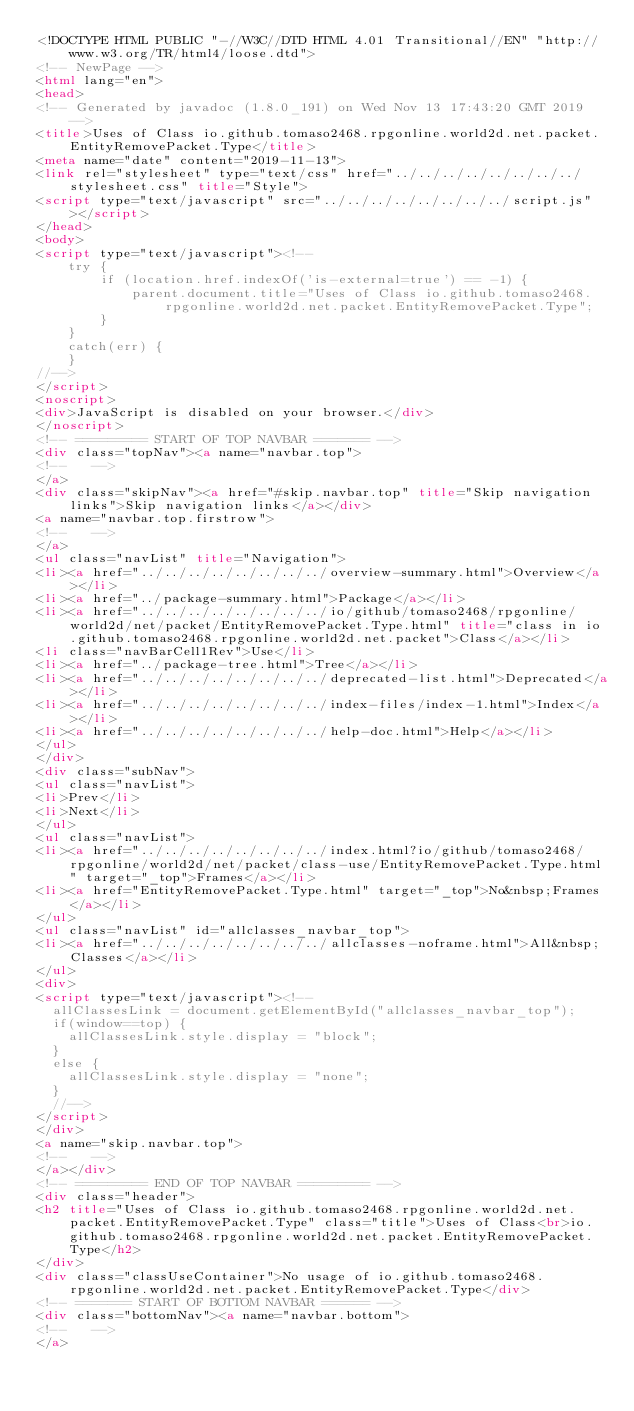Convert code to text. <code><loc_0><loc_0><loc_500><loc_500><_HTML_><!DOCTYPE HTML PUBLIC "-//W3C//DTD HTML 4.01 Transitional//EN" "http://www.w3.org/TR/html4/loose.dtd">
<!-- NewPage -->
<html lang="en">
<head>
<!-- Generated by javadoc (1.8.0_191) on Wed Nov 13 17:43:20 GMT 2019 -->
<title>Uses of Class io.github.tomaso2468.rpgonline.world2d.net.packet.EntityRemovePacket.Type</title>
<meta name="date" content="2019-11-13">
<link rel="stylesheet" type="text/css" href="../../../../../../../../stylesheet.css" title="Style">
<script type="text/javascript" src="../../../../../../../../script.js"></script>
</head>
<body>
<script type="text/javascript"><!--
    try {
        if (location.href.indexOf('is-external=true') == -1) {
            parent.document.title="Uses of Class io.github.tomaso2468.rpgonline.world2d.net.packet.EntityRemovePacket.Type";
        }
    }
    catch(err) {
    }
//-->
</script>
<noscript>
<div>JavaScript is disabled on your browser.</div>
</noscript>
<!-- ========= START OF TOP NAVBAR ======= -->
<div class="topNav"><a name="navbar.top">
<!--   -->
</a>
<div class="skipNav"><a href="#skip.navbar.top" title="Skip navigation links">Skip navigation links</a></div>
<a name="navbar.top.firstrow">
<!--   -->
</a>
<ul class="navList" title="Navigation">
<li><a href="../../../../../../../../overview-summary.html">Overview</a></li>
<li><a href="../package-summary.html">Package</a></li>
<li><a href="../../../../../../../../io/github/tomaso2468/rpgonline/world2d/net/packet/EntityRemovePacket.Type.html" title="class in io.github.tomaso2468.rpgonline.world2d.net.packet">Class</a></li>
<li class="navBarCell1Rev">Use</li>
<li><a href="../package-tree.html">Tree</a></li>
<li><a href="../../../../../../../../deprecated-list.html">Deprecated</a></li>
<li><a href="../../../../../../../../index-files/index-1.html">Index</a></li>
<li><a href="../../../../../../../../help-doc.html">Help</a></li>
</ul>
</div>
<div class="subNav">
<ul class="navList">
<li>Prev</li>
<li>Next</li>
</ul>
<ul class="navList">
<li><a href="../../../../../../../../index.html?io/github/tomaso2468/rpgonline/world2d/net/packet/class-use/EntityRemovePacket.Type.html" target="_top">Frames</a></li>
<li><a href="EntityRemovePacket.Type.html" target="_top">No&nbsp;Frames</a></li>
</ul>
<ul class="navList" id="allclasses_navbar_top">
<li><a href="../../../../../../../../allclasses-noframe.html">All&nbsp;Classes</a></li>
</ul>
<div>
<script type="text/javascript"><!--
  allClassesLink = document.getElementById("allclasses_navbar_top");
  if(window==top) {
    allClassesLink.style.display = "block";
  }
  else {
    allClassesLink.style.display = "none";
  }
  //-->
</script>
</div>
<a name="skip.navbar.top">
<!--   -->
</a></div>
<!-- ========= END OF TOP NAVBAR ========= -->
<div class="header">
<h2 title="Uses of Class io.github.tomaso2468.rpgonline.world2d.net.packet.EntityRemovePacket.Type" class="title">Uses of Class<br>io.github.tomaso2468.rpgonline.world2d.net.packet.EntityRemovePacket.Type</h2>
</div>
<div class="classUseContainer">No usage of io.github.tomaso2468.rpgonline.world2d.net.packet.EntityRemovePacket.Type</div>
<!-- ======= START OF BOTTOM NAVBAR ====== -->
<div class="bottomNav"><a name="navbar.bottom">
<!--   -->
</a></code> 